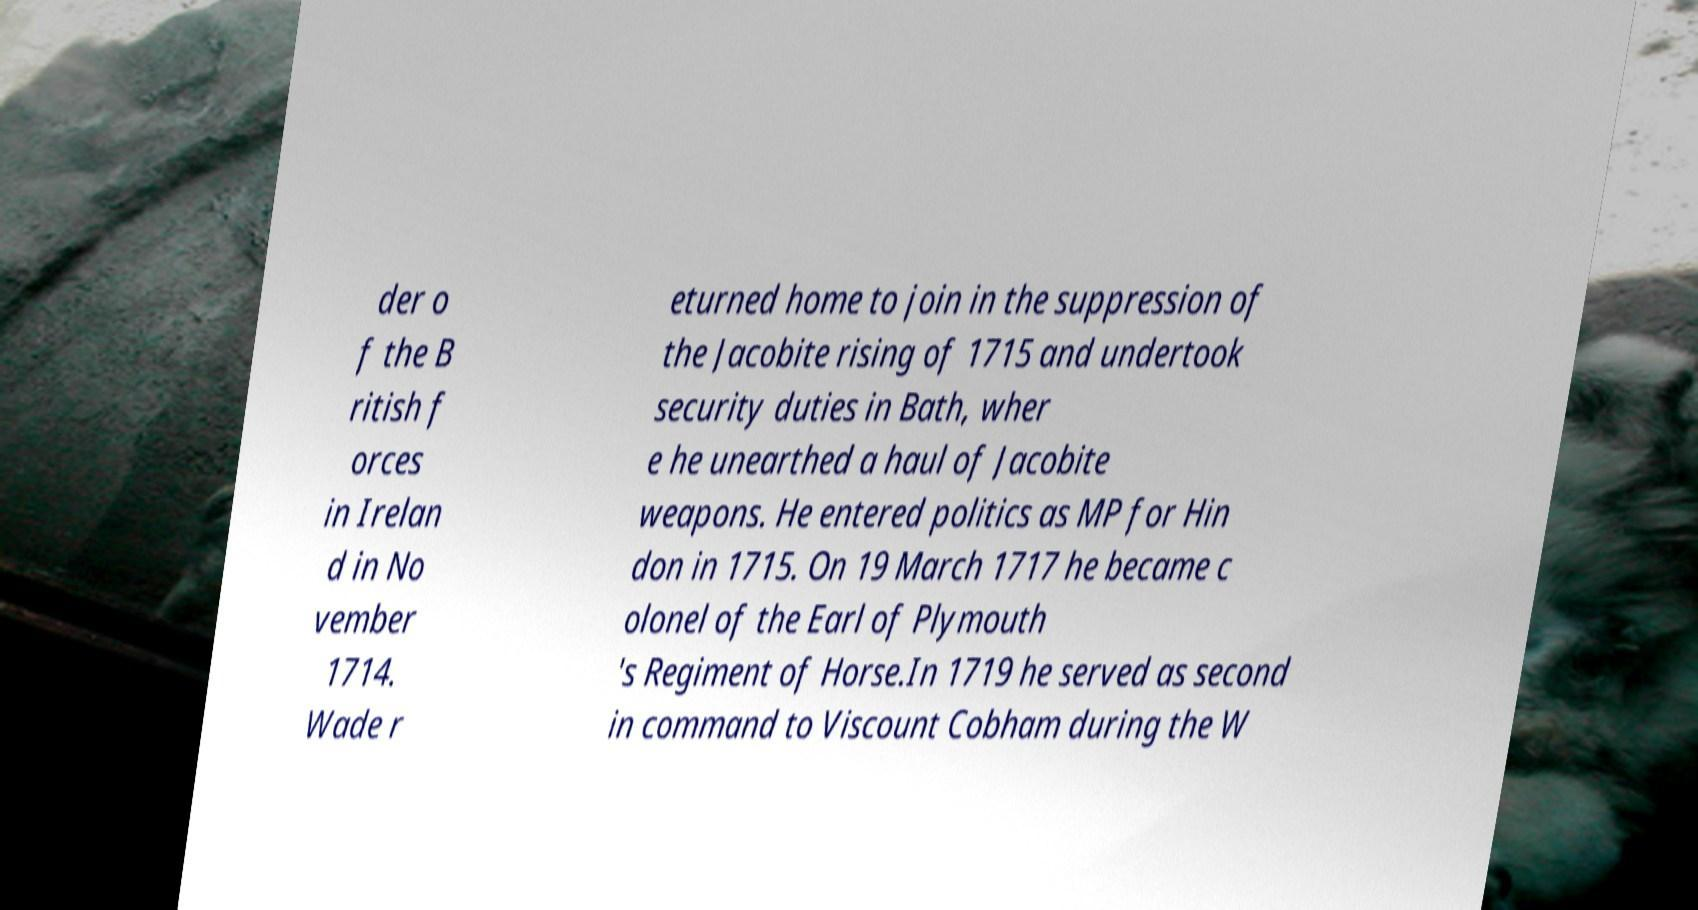Please identify and transcribe the text found in this image. der o f the B ritish f orces in Irelan d in No vember 1714. Wade r eturned home to join in the suppression of the Jacobite rising of 1715 and undertook security duties in Bath, wher e he unearthed a haul of Jacobite weapons. He entered politics as MP for Hin don in 1715. On 19 March 1717 he became c olonel of the Earl of Plymouth 's Regiment of Horse.In 1719 he served as second in command to Viscount Cobham during the W 